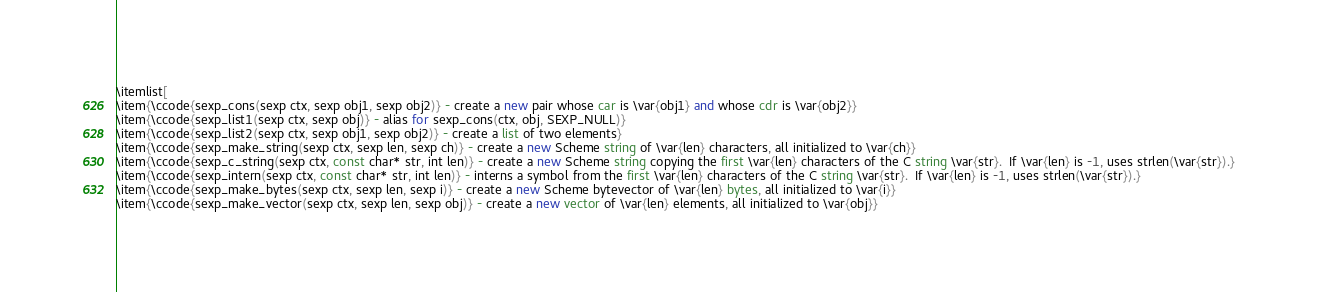Convert code to text. <code><loc_0><loc_0><loc_500><loc_500><_Racket_>
\itemlist[
\item{\ccode{sexp_cons(sexp ctx, sexp obj1, sexp obj2)} - create a new pair whose car is \var{obj1} and whose cdr is \var{obj2}}
\item{\ccode{sexp_list1(sexp ctx, sexp obj)} - alias for sexp_cons(ctx, obj, SEXP_NULL)}
\item{\ccode{sexp_list2(sexp ctx, sexp obj1, sexp obj2)} - create a list of two elements}
\item{\ccode{sexp_make_string(sexp ctx, sexp len, sexp ch)} - create a new Scheme string of \var{len} characters, all initialized to \var{ch}}
\item{\ccode{sexp_c_string(sexp ctx, const char* str, int len)} - create a new Scheme string copying the first \var{len} characters of the C string \var{str}.  If \var{len} is -1, uses strlen(\var{str}).}
\item{\ccode{sexp_intern(sexp ctx, const char* str, int len)} - interns a symbol from the first \var{len} characters of the C string \var{str}.  If \var{len} is -1, uses strlen(\var{str}).}
\item{\ccode{sexp_make_bytes(sexp ctx, sexp len, sexp i)} - create a new Scheme bytevector of \var{len} bytes, all initialized to \var{i}}
\item{\ccode{sexp_make_vector(sexp ctx, sexp len, sexp obj)} - create a new vector of \var{len} elements, all initialized to \var{obj}}</code> 